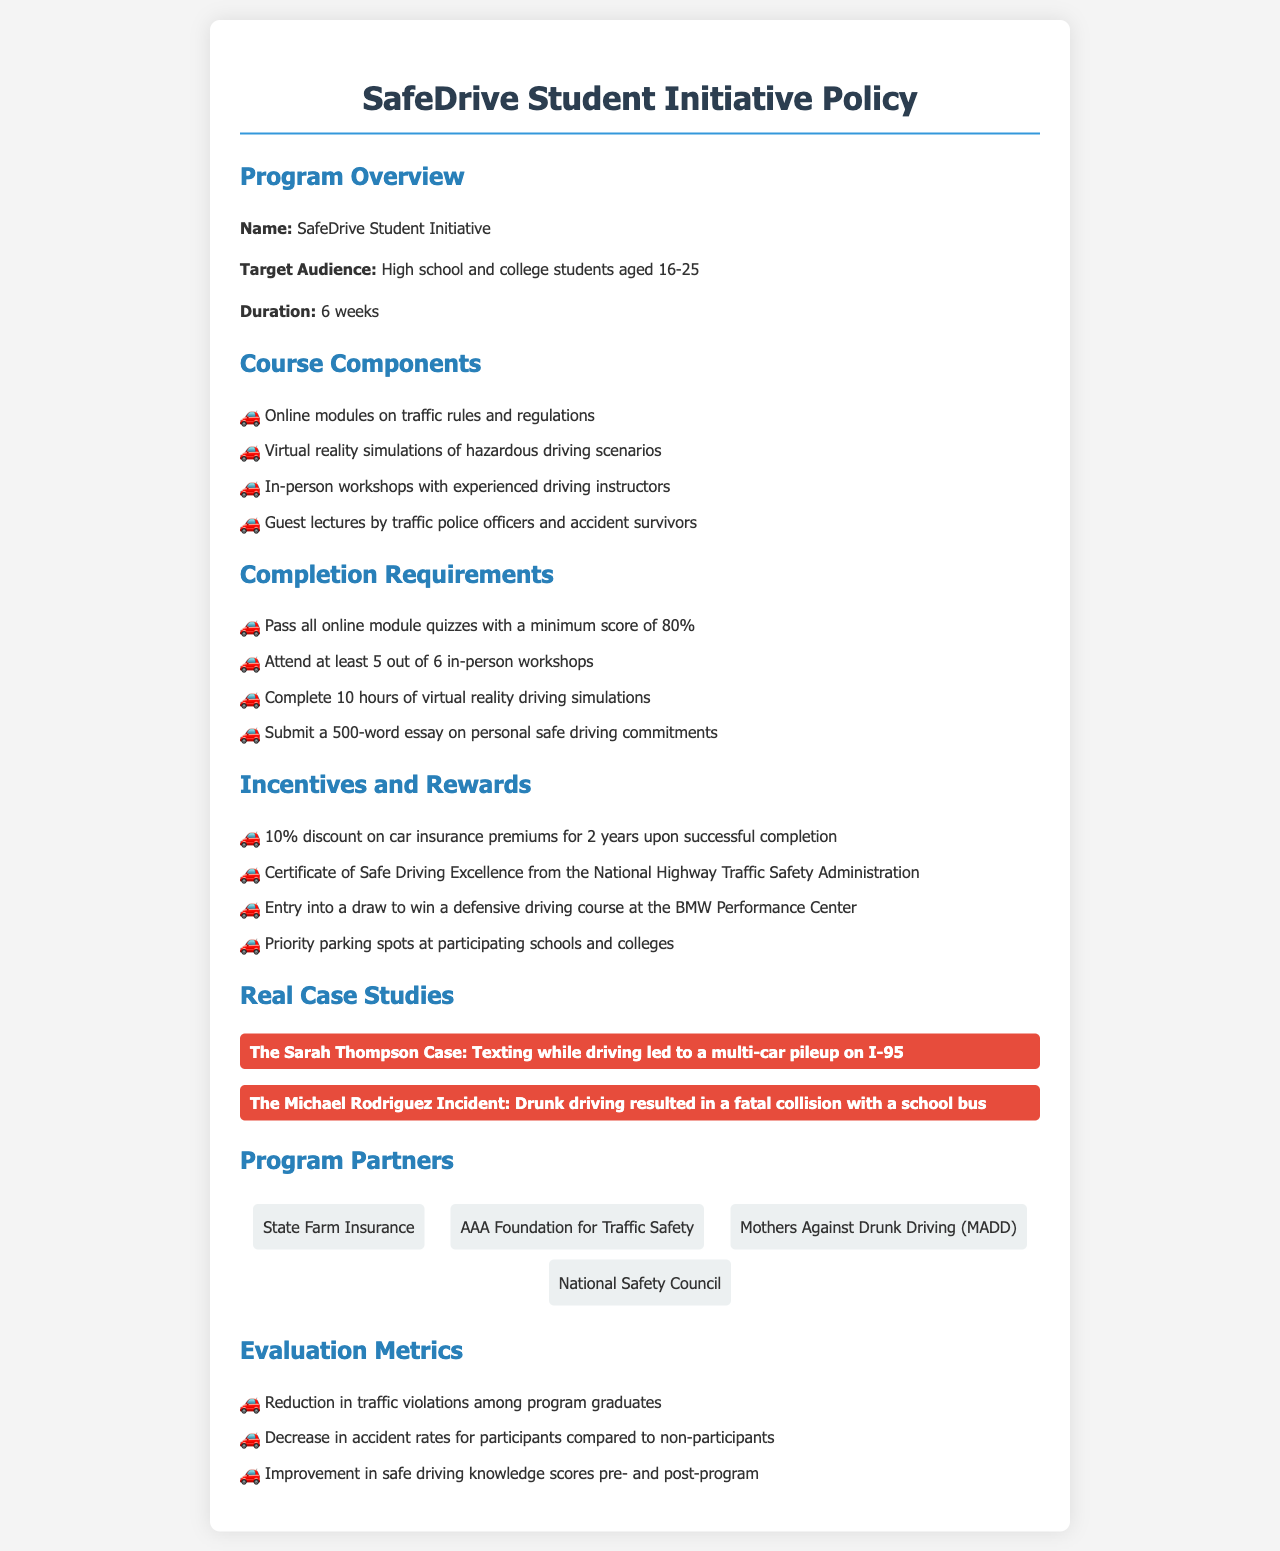What is the target audience for the program? The target audience for the SafeDrive Student Initiative is high school and college students aged 16-25.
Answer: high school and college students aged 16-25 How long is the duration of the program? The duration of the program is specified in weeks within the document.
Answer: 6 weeks What is one of the requirements to complete the program? The document lists specific requirements to complete the program, focusing on assessments and attendance.
Answer: Pass all online module quizzes with a minimum score of 80% What incentive is offered for successful completion? The document outlines several incentives for completing the program, one of which is mentioned specifically.
Answer: 10% discount on car insurance premiums for 2 years Who is a partner of the program? Several organizations are listed as partners within the document, one of which can be identified easily.
Answer: State Farm Insurance What is a key focus of the real case studies section? The document includes specific case studies to emphasize the importance of safe driving.
Answer: Texting while driving led to a multi-car pileup on I-95 What is the improvement metric mentioned for participants? The evaluation metrics specify what improvements should be measured among participants post-program completion.
Answer: Improvement in safe driving knowledge scores pre- and post-program What document type is this initiative classified as? The structure and content indicate the initiative is characterized as a particular type of formal publication.
Answer: policy document 